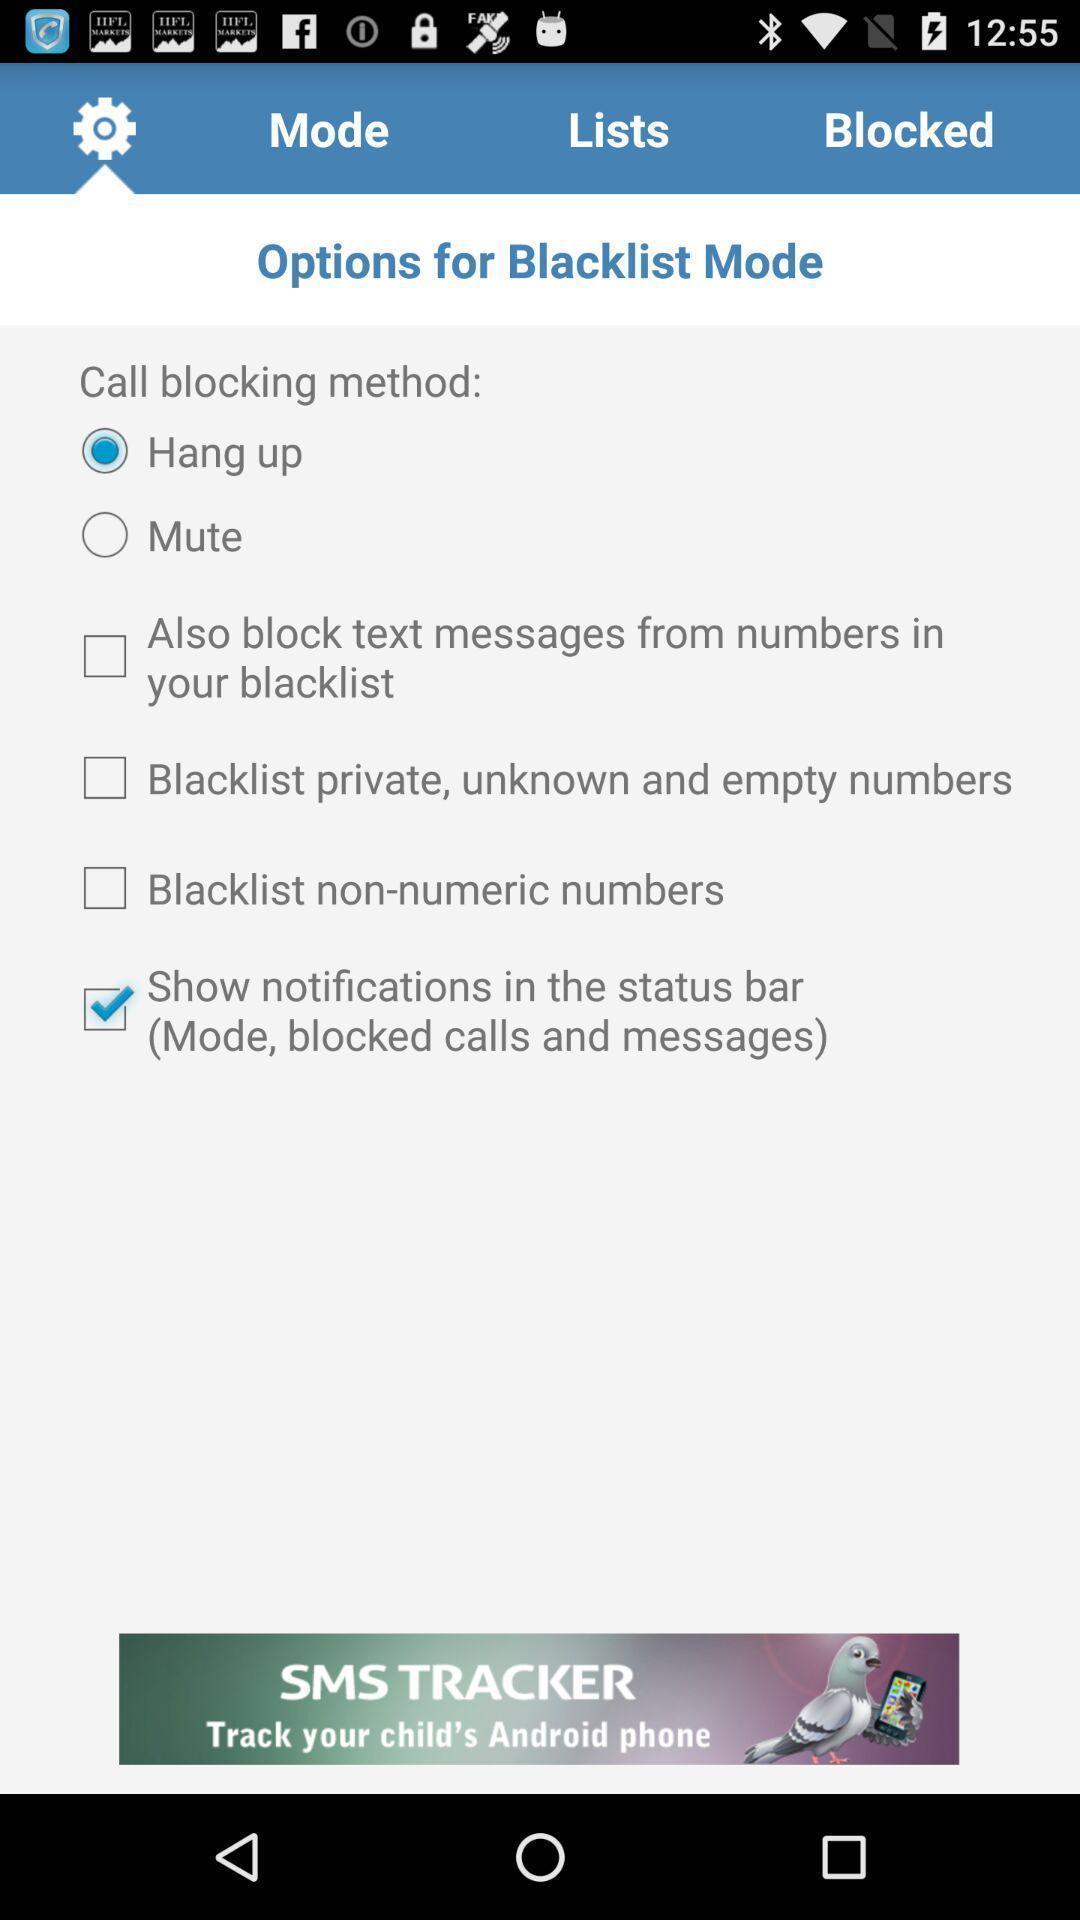Describe the key features of this screenshot. Settings page. 